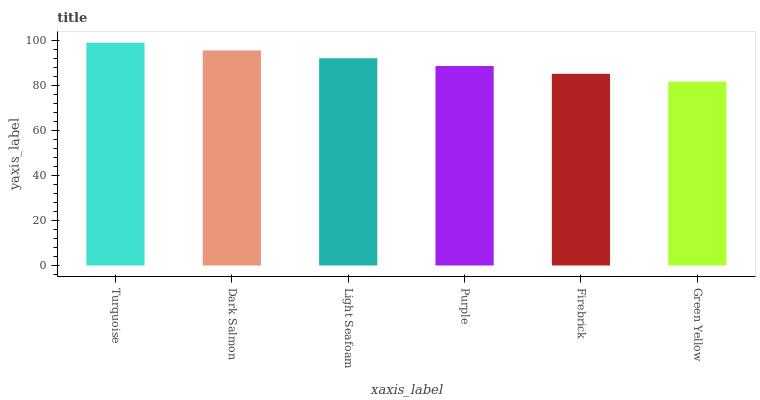Is Green Yellow the minimum?
Answer yes or no. Yes. Is Turquoise the maximum?
Answer yes or no. Yes. Is Dark Salmon the minimum?
Answer yes or no. No. Is Dark Salmon the maximum?
Answer yes or no. No. Is Turquoise greater than Dark Salmon?
Answer yes or no. Yes. Is Dark Salmon less than Turquoise?
Answer yes or no. Yes. Is Dark Salmon greater than Turquoise?
Answer yes or no. No. Is Turquoise less than Dark Salmon?
Answer yes or no. No. Is Light Seafoam the high median?
Answer yes or no. Yes. Is Purple the low median?
Answer yes or no. Yes. Is Firebrick the high median?
Answer yes or no. No. Is Dark Salmon the low median?
Answer yes or no. No. 